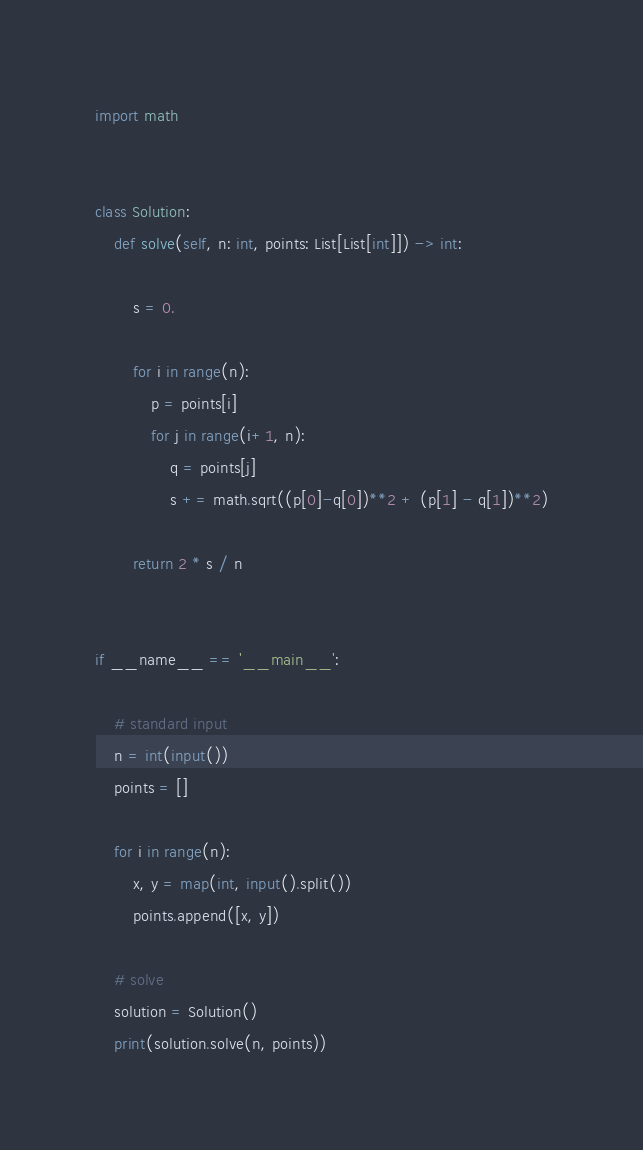Convert code to text. <code><loc_0><loc_0><loc_500><loc_500><_Python_>import math


class Solution:
    def solve(self, n: int, points: List[List[int]]) -> int:

        s = 0.

        for i in range(n):
            p = points[i]
            for j in range(i+1, n):
                q = points[j]
                s += math.sqrt((p[0]-q[0])**2 + (p[1] - q[1])**2)

        return 2 * s / n


if __name__ == '__main__':

    # standard input
    n = int(input())
    points = []

    for i in range(n):
        x, y = map(int, input().split())
        points.append([x, y])

    # solve
    solution = Solution()
    print(solution.solve(n, points))
</code> 